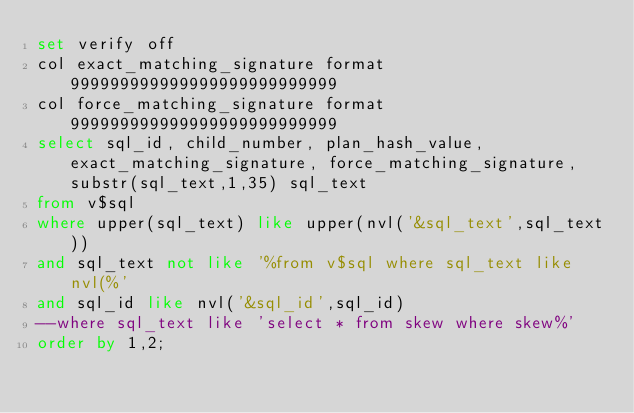<code> <loc_0><loc_0><loc_500><loc_500><_SQL_>set verify off
col exact_matching_signature format 999999999999999999999999999
col force_matching_signature format 999999999999999999999999999
select sql_id, child_number, plan_hash_value, exact_matching_signature, force_matching_signature, substr(sql_text,1,35) sql_text
from v$sql 
where upper(sql_text) like upper(nvl('&sql_text',sql_text))
and sql_text not like '%from v$sql where sql_text like nvl(%'
and sql_id like nvl('&sql_id',sql_id)
--where sql_text like 'select * from skew where skew%'
order by 1,2;
</code> 